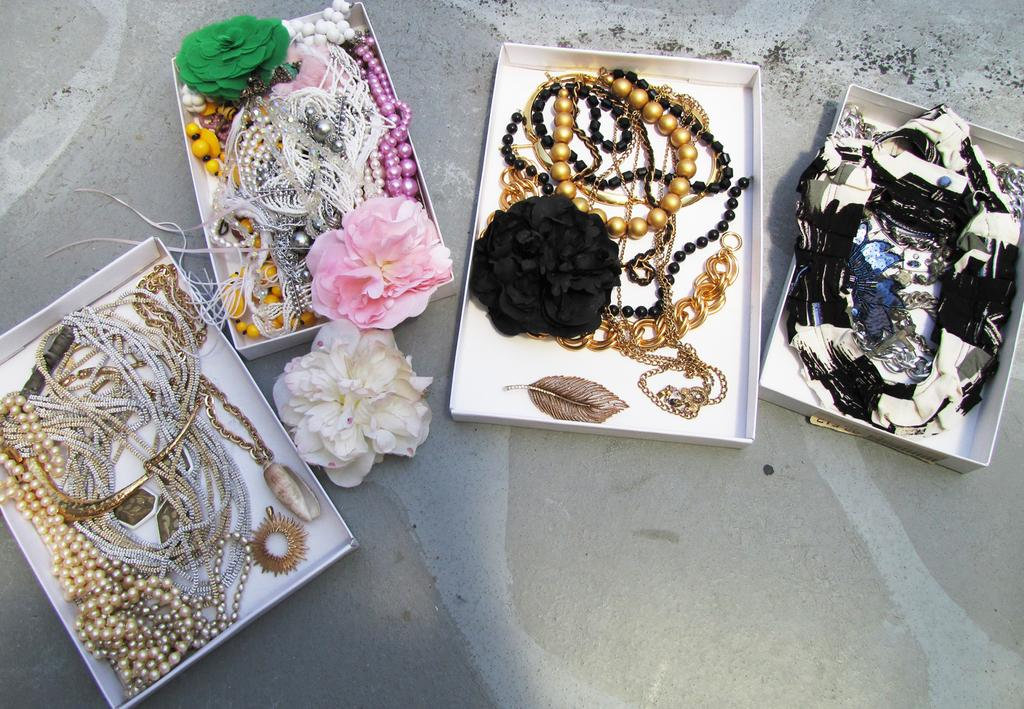What type of jewelry is present in the image? There are pearl chains in the image. What other objects can be seen in the image? There are flowers and a feather visible in the image. What are the ornaments stored in? The ornaments are stored in boxes in the image. Can you describe the white flower in the image? There is a white flower on the surface in the image. How many dinosaurs can be seen interacting with the pearl chains in the image? There are no dinosaurs present in the image; it features pearl chains, flowers, a feather, ornaments in boxes, and a white flower on the surface. Can you describe the texture of the moon in the image? There is no moon present in the image. 